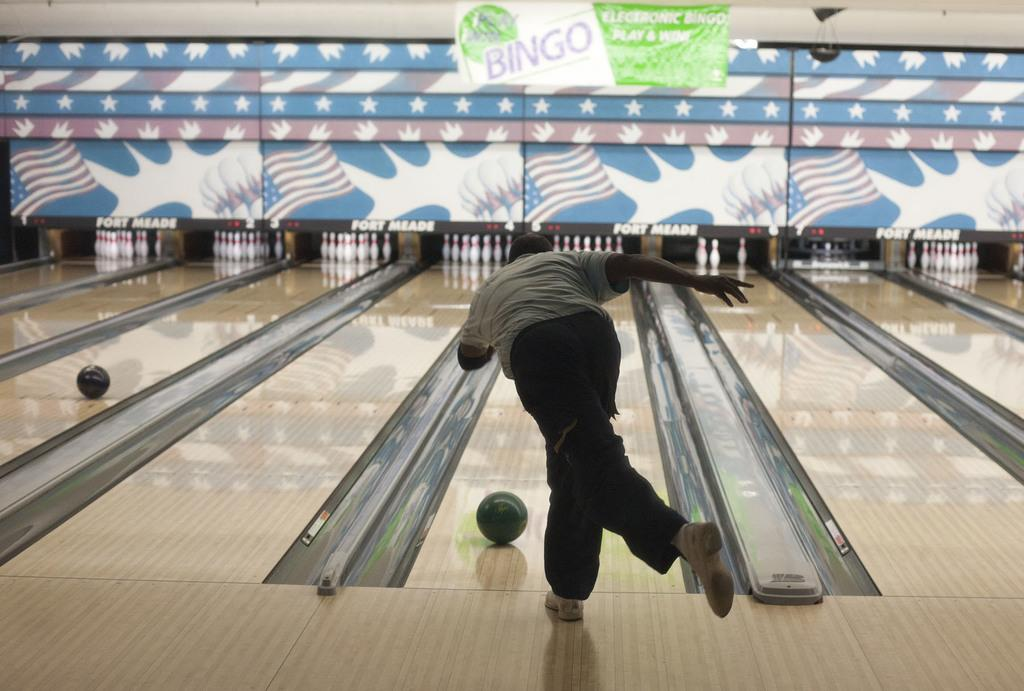Who is the main subject in the image? There is a man in the center of the image. What is the man doing in the image? The man is playing a bowling game. What can be seen in the background of the image? There is a wall and a flex in the background of the image. What type of brain can be seen in the image? There is no brain present in the image. Can you describe the bat that is flying in the background of the image? There is no bat present in the image. 